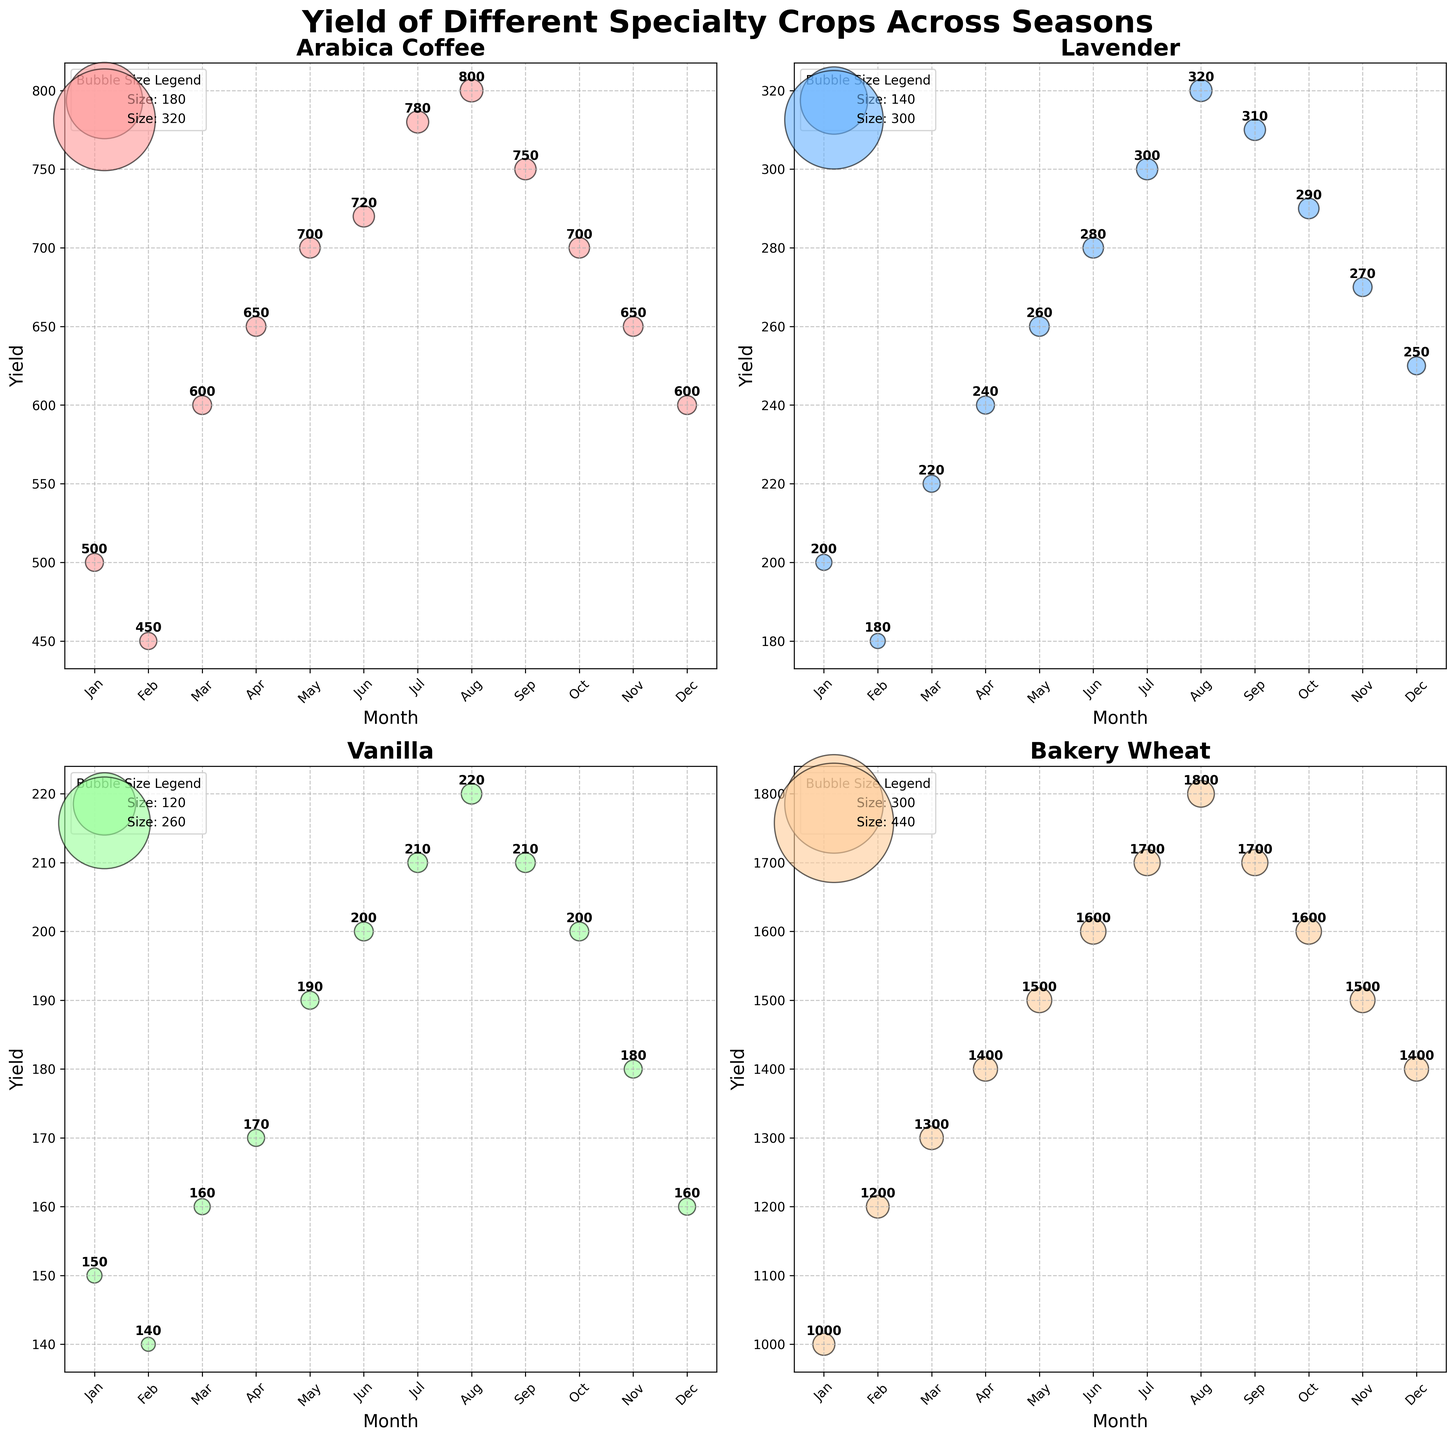what is the title of the figure? The title of the figure is displayed at the top center of the plot. It reads 'Yield of Different Specialty Crops Across Seasons', which is a bold and large font size.
Answer: Yield of Different Specialty Crops Across Seasons Which month has the highest yield for Arabica Coffee? The yield for Arabica Coffee is highest in August, as indicated by the highest bubble on the y-axis in the subplot for Arabica Coffee, which reaches 800.
Answer: August What is the trend of Lavender yield from January to December? Observing the subplot for Lavender, the yield generally shows an upward trend from January (200) to August (320) and then slightly decreases towards December (250).
Answer: Upward till August, then slightly downward How does the yield of Bakery Wheat in February compare to that in October? The subplot for Bakery Wheat shows that the yield in February is 1200, whereas in October it is 1600. By comparing these values, the yield in October is higher than in February.
Answer: October is higher Which crop has the largest bubble size in its maximum yield month? The bubble sizes are a visual representation of the 'Size' column. In the subplot for Bakery Wheat, the maximum bubble size corresponds to August (22). Therefore, Bakery Wheat has the largest bubble size in its maximum yield month.
Answer: Bakery Wheat What is the average yield of Vanilla across the year? To find the average yield of Vanilla across the year, sum the monthly yields (150 + 140 + 160 + 170 + 190 + 200 + 210 + 220 + 210 + 200 + 180 + 160) which equals 2290. Divide by 12 (number of months), resulting in an average yield of approximately 190.83.
Answer: 190.83 How does the yield trend of Arabica Coffee compare to that of Vanilla from July to December? Observing both subplots from July to December, Arabica Coffee's yield decreases from 780 to 600, while Vanilla's yield also decreases but at a different rate from 210 to 160. Both show a downward trend.
Answer: Both show a downward trend What is the difference in the maximum yield between Arabica Coffee and Lavender? The maximum yield for Arabica Coffee is 800 (in August) and for Lavender is 320 (also in August). The difference is 800 - 320 = 480.
Answer: 480 What is the total yield for Bakery Wheat in the first quarter of the year? The first quarter includes January, February, and March. Adding the yields: 1000 (Jan) + 1200 (Feb) + 1300 (Mar) = 3500.
Answer: 3500 